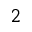<formula> <loc_0><loc_0><loc_500><loc_500>^ { 2 }</formula> 